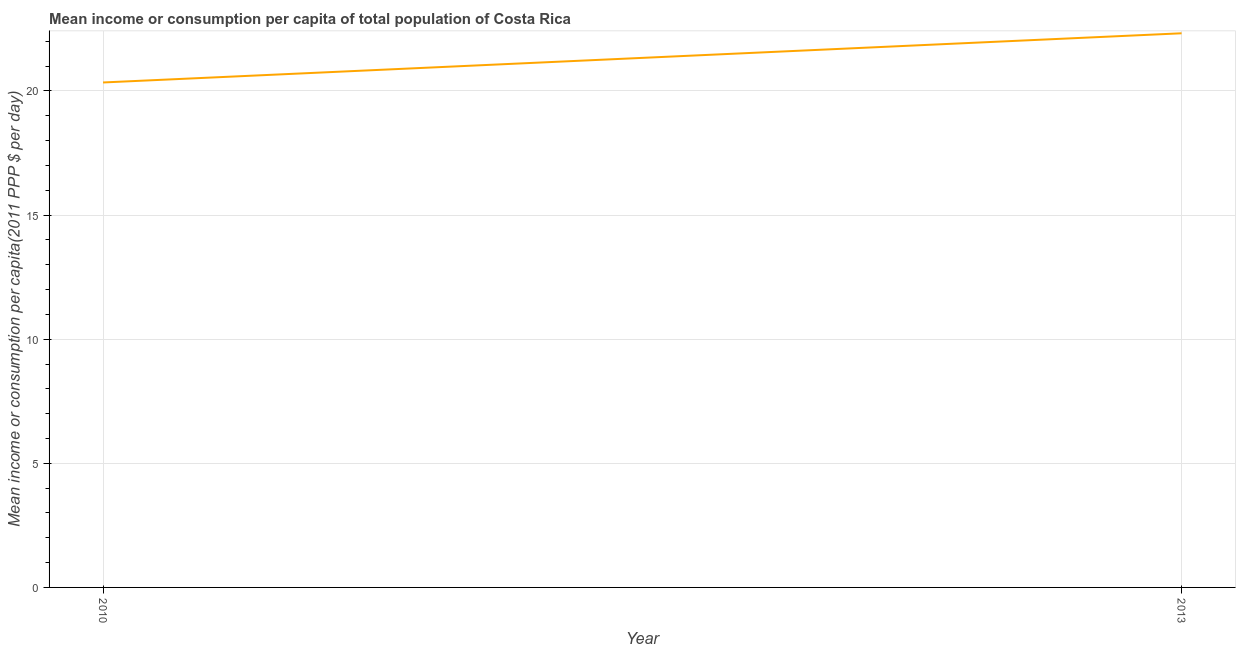What is the mean income or consumption in 2013?
Your answer should be compact. 22.32. Across all years, what is the maximum mean income or consumption?
Provide a succinct answer. 22.32. Across all years, what is the minimum mean income or consumption?
Ensure brevity in your answer.  20.34. In which year was the mean income or consumption minimum?
Your answer should be compact. 2010. What is the sum of the mean income or consumption?
Ensure brevity in your answer.  42.66. What is the difference between the mean income or consumption in 2010 and 2013?
Your answer should be compact. -1.98. What is the average mean income or consumption per year?
Make the answer very short. 21.33. What is the median mean income or consumption?
Your answer should be very brief. 21.33. What is the ratio of the mean income or consumption in 2010 to that in 2013?
Your answer should be very brief. 0.91. In how many years, is the mean income or consumption greater than the average mean income or consumption taken over all years?
Offer a terse response. 1. How many years are there in the graph?
Your answer should be very brief. 2. What is the difference between two consecutive major ticks on the Y-axis?
Provide a short and direct response. 5. Are the values on the major ticks of Y-axis written in scientific E-notation?
Ensure brevity in your answer.  No. Does the graph contain any zero values?
Give a very brief answer. No. What is the title of the graph?
Offer a very short reply. Mean income or consumption per capita of total population of Costa Rica. What is the label or title of the Y-axis?
Your answer should be compact. Mean income or consumption per capita(2011 PPP $ per day). What is the Mean income or consumption per capita(2011 PPP $ per day) in 2010?
Your answer should be compact. 20.34. What is the Mean income or consumption per capita(2011 PPP $ per day) in 2013?
Your response must be concise. 22.32. What is the difference between the Mean income or consumption per capita(2011 PPP $ per day) in 2010 and 2013?
Your response must be concise. -1.98. What is the ratio of the Mean income or consumption per capita(2011 PPP $ per day) in 2010 to that in 2013?
Your answer should be very brief. 0.91. 